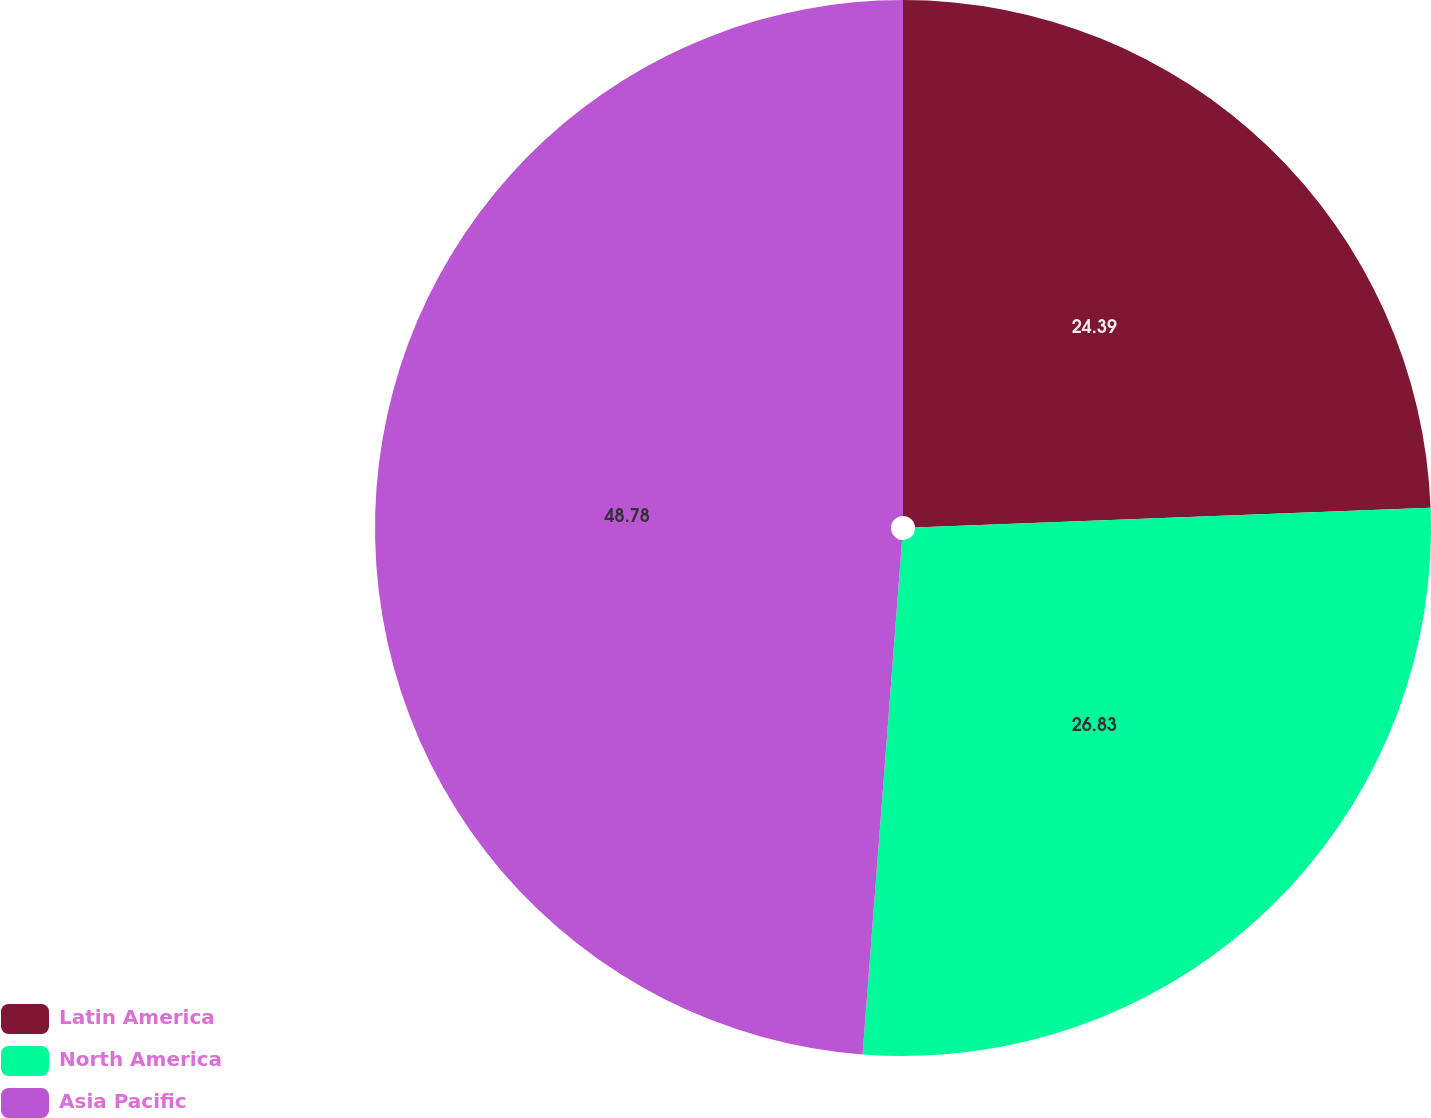Convert chart to OTSL. <chart><loc_0><loc_0><loc_500><loc_500><pie_chart><fcel>Latin America<fcel>North America<fcel>Asia Pacific<nl><fcel>24.39%<fcel>26.83%<fcel>48.78%<nl></chart> 